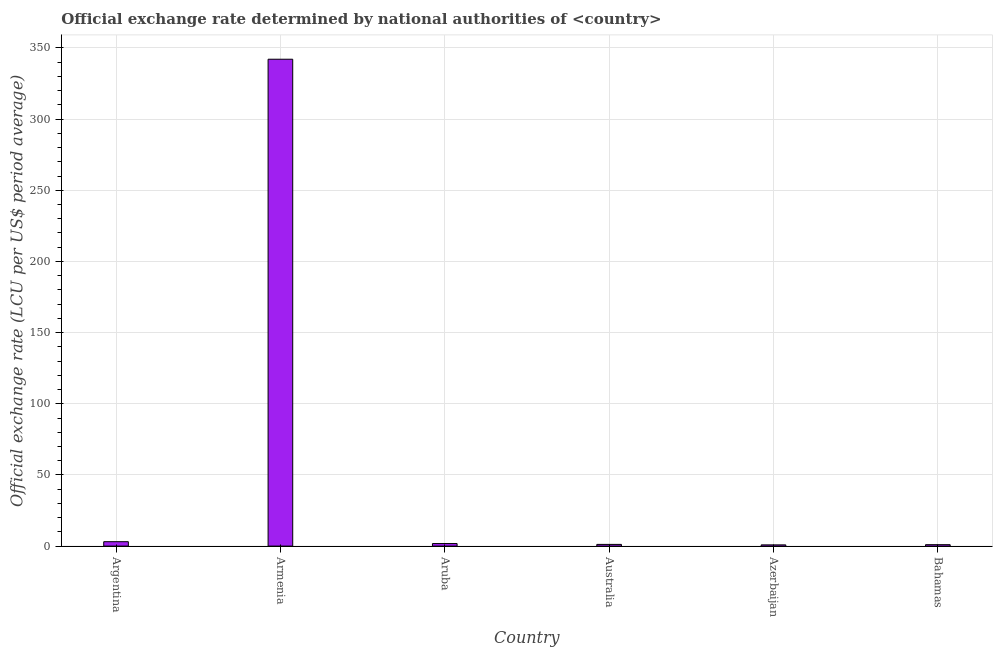Does the graph contain grids?
Keep it short and to the point. Yes. What is the title of the graph?
Give a very brief answer. Official exchange rate determined by national authorities of <country>. What is the label or title of the X-axis?
Make the answer very short. Country. What is the label or title of the Y-axis?
Your answer should be very brief. Official exchange rate (LCU per US$ period average). What is the official exchange rate in Argentina?
Your response must be concise. 3.1. Across all countries, what is the maximum official exchange rate?
Provide a short and direct response. 342.08. Across all countries, what is the minimum official exchange rate?
Give a very brief answer. 0.86. In which country was the official exchange rate maximum?
Offer a terse response. Armenia. In which country was the official exchange rate minimum?
Your response must be concise. Azerbaijan. What is the sum of the official exchange rate?
Offer a terse response. 350.02. What is the difference between the official exchange rate in Armenia and Bahamas?
Provide a succinct answer. 341.08. What is the average official exchange rate per country?
Ensure brevity in your answer.  58.34. What is the median official exchange rate?
Offer a very short reply. 1.49. In how many countries, is the official exchange rate greater than 340 ?
Your answer should be very brief. 1. What is the ratio of the official exchange rate in Armenia to that in Bahamas?
Ensure brevity in your answer.  342.08. Is the difference between the official exchange rate in Aruba and Azerbaijan greater than the difference between any two countries?
Give a very brief answer. No. What is the difference between the highest and the second highest official exchange rate?
Offer a terse response. 338.98. What is the difference between the highest and the lowest official exchange rate?
Provide a succinct answer. 341.22. In how many countries, is the official exchange rate greater than the average official exchange rate taken over all countries?
Ensure brevity in your answer.  1. How many bars are there?
Ensure brevity in your answer.  6. What is the difference between two consecutive major ticks on the Y-axis?
Your answer should be compact. 50. What is the Official exchange rate (LCU per US$ period average) of Argentina?
Provide a succinct answer. 3.1. What is the Official exchange rate (LCU per US$ period average) of Armenia?
Give a very brief answer. 342.08. What is the Official exchange rate (LCU per US$ period average) of Aruba?
Provide a succinct answer. 1.79. What is the Official exchange rate (LCU per US$ period average) in Australia?
Your response must be concise. 1.2. What is the Official exchange rate (LCU per US$ period average) in Azerbaijan?
Give a very brief answer. 0.86. What is the difference between the Official exchange rate (LCU per US$ period average) in Argentina and Armenia?
Keep it short and to the point. -338.98. What is the difference between the Official exchange rate (LCU per US$ period average) in Argentina and Aruba?
Offer a very short reply. 1.31. What is the difference between the Official exchange rate (LCU per US$ period average) in Argentina and Australia?
Offer a terse response. 1.9. What is the difference between the Official exchange rate (LCU per US$ period average) in Argentina and Azerbaijan?
Provide a succinct answer. 2.24. What is the difference between the Official exchange rate (LCU per US$ period average) in Argentina and Bahamas?
Offer a terse response. 2.1. What is the difference between the Official exchange rate (LCU per US$ period average) in Armenia and Aruba?
Offer a very short reply. 340.29. What is the difference between the Official exchange rate (LCU per US$ period average) in Armenia and Australia?
Your answer should be compact. 340.88. What is the difference between the Official exchange rate (LCU per US$ period average) in Armenia and Azerbaijan?
Your response must be concise. 341.22. What is the difference between the Official exchange rate (LCU per US$ period average) in Armenia and Bahamas?
Give a very brief answer. 341.08. What is the difference between the Official exchange rate (LCU per US$ period average) in Aruba and Australia?
Ensure brevity in your answer.  0.59. What is the difference between the Official exchange rate (LCU per US$ period average) in Aruba and Azerbaijan?
Provide a succinct answer. 0.93. What is the difference between the Official exchange rate (LCU per US$ period average) in Aruba and Bahamas?
Your response must be concise. 0.79. What is the difference between the Official exchange rate (LCU per US$ period average) in Australia and Azerbaijan?
Your response must be concise. 0.34. What is the difference between the Official exchange rate (LCU per US$ period average) in Australia and Bahamas?
Provide a succinct answer. 0.2. What is the difference between the Official exchange rate (LCU per US$ period average) in Azerbaijan and Bahamas?
Your answer should be very brief. -0.14. What is the ratio of the Official exchange rate (LCU per US$ period average) in Argentina to that in Armenia?
Give a very brief answer. 0.01. What is the ratio of the Official exchange rate (LCU per US$ period average) in Argentina to that in Aruba?
Make the answer very short. 1.73. What is the ratio of the Official exchange rate (LCU per US$ period average) in Argentina to that in Australia?
Ensure brevity in your answer.  2.59. What is the ratio of the Official exchange rate (LCU per US$ period average) in Argentina to that in Azerbaijan?
Your answer should be compact. 3.61. What is the ratio of the Official exchange rate (LCU per US$ period average) in Argentina to that in Bahamas?
Your answer should be compact. 3.1. What is the ratio of the Official exchange rate (LCU per US$ period average) in Armenia to that in Aruba?
Make the answer very short. 191.11. What is the ratio of the Official exchange rate (LCU per US$ period average) in Armenia to that in Australia?
Your answer should be compact. 286.24. What is the ratio of the Official exchange rate (LCU per US$ period average) in Armenia to that in Azerbaijan?
Ensure brevity in your answer.  398.64. What is the ratio of the Official exchange rate (LCU per US$ period average) in Armenia to that in Bahamas?
Provide a succinct answer. 342.08. What is the ratio of the Official exchange rate (LCU per US$ period average) in Aruba to that in Australia?
Provide a short and direct response. 1.5. What is the ratio of the Official exchange rate (LCU per US$ period average) in Aruba to that in Azerbaijan?
Offer a very short reply. 2.09. What is the ratio of the Official exchange rate (LCU per US$ period average) in Aruba to that in Bahamas?
Ensure brevity in your answer.  1.79. What is the ratio of the Official exchange rate (LCU per US$ period average) in Australia to that in Azerbaijan?
Keep it short and to the point. 1.39. What is the ratio of the Official exchange rate (LCU per US$ period average) in Australia to that in Bahamas?
Keep it short and to the point. 1.2. What is the ratio of the Official exchange rate (LCU per US$ period average) in Azerbaijan to that in Bahamas?
Keep it short and to the point. 0.86. 